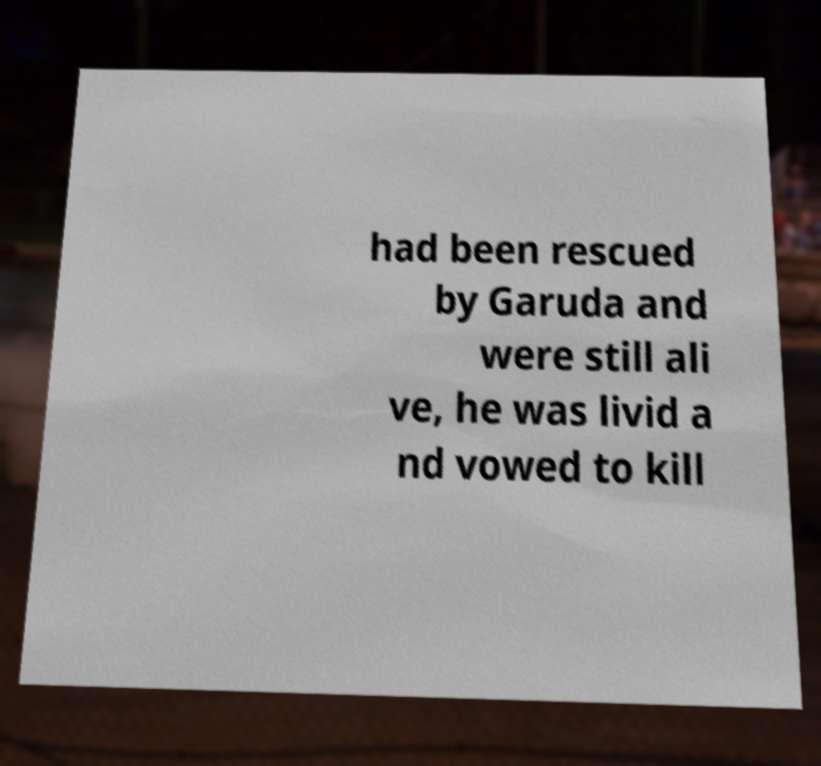Could you extract and type out the text from this image? had been rescued by Garuda and were still ali ve, he was livid a nd vowed to kill 